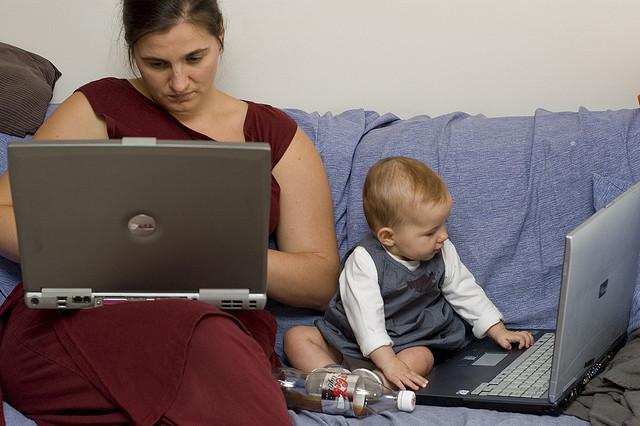Who was drinking from the coke bottle?

Choices:
A) couch
B) woman
C) baby
D) computer woman 